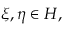<formula> <loc_0><loc_0><loc_500><loc_500>\xi , \eta \in H ,</formula> 